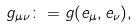Convert formula to latex. <formula><loc_0><loc_0><loc_500><loc_500>g _ { \mu \nu } \colon = g ( { e } _ { \mu } , { e } _ { \nu } ) ,</formula> 